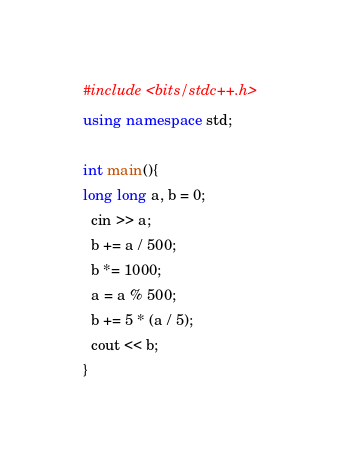Convert code to text. <code><loc_0><loc_0><loc_500><loc_500><_C++_>#include <bits/stdc++.h>
using namespace std;

int main(){
long long a, b = 0;
  cin >> a;
  b += a / 500;
  b *= 1000;
  a = a % 500;
  b += 5 * (a / 5);
  cout << b;
}</code> 